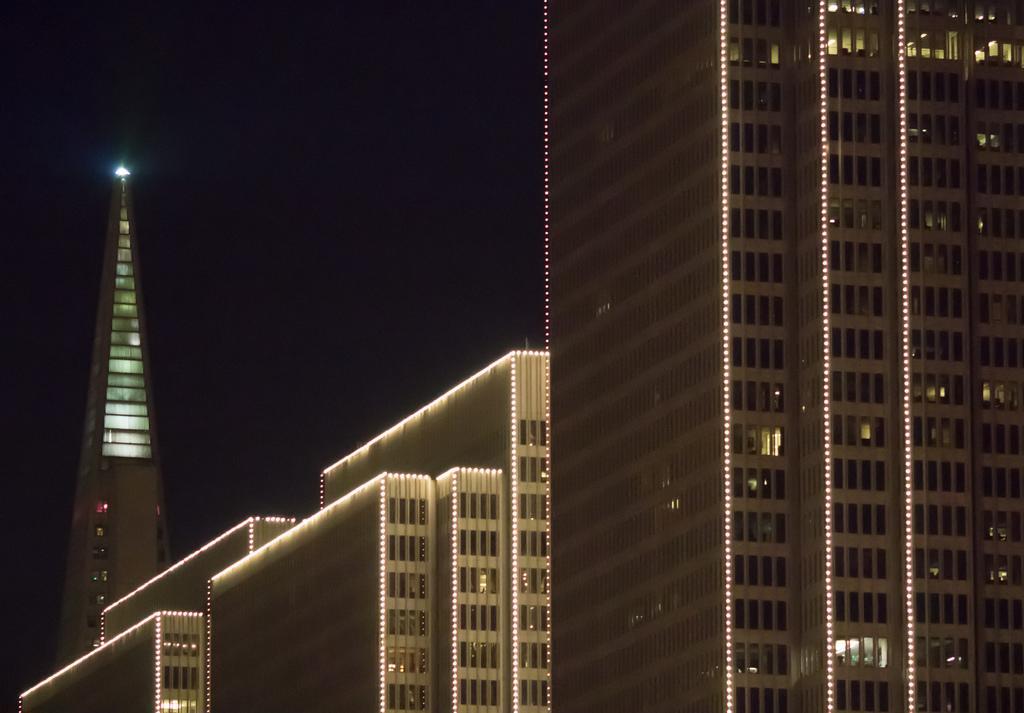Describe this image in one or two sentences. In this image I can see buildings with lights. To the left side of the image there is a building with triangular shape and in the centre of the image there are different sizes of buildings. 